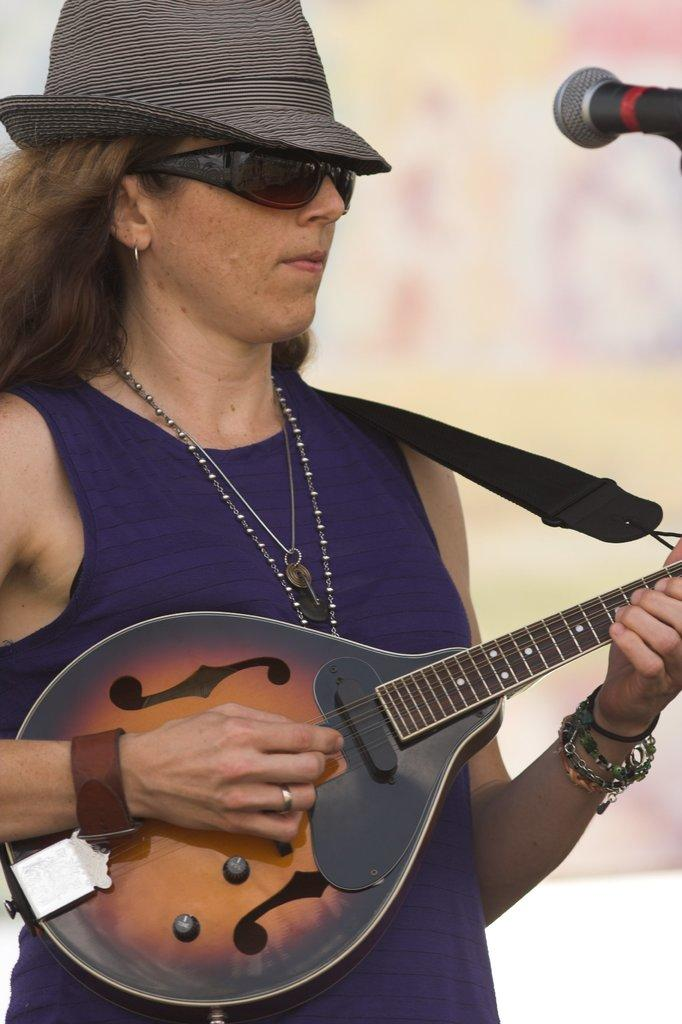What color is the t-shirt the woman is wearing in the image? The woman is wearing a purple t-shirt. What accessories is the woman wearing in the image? The woman is wearing a chain, a hat, and goggles. What is the woman doing in the image? The woman is playing a guitar and standing in front of a microphone. What size of coat is the woman wearing in the image? There is no coat visible in the image; the woman is wearing a purple t-shirt, a hat, and goggles. Where can we find the store where the woman bought her goggles? The facts provided do not mention a store, so we cannot determine where the woman bought her goggles. 